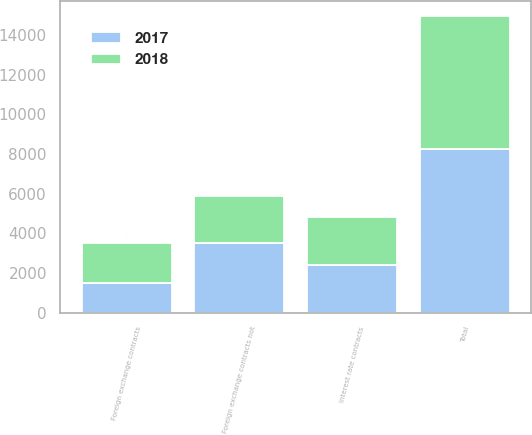Convert chart. <chart><loc_0><loc_0><loc_500><loc_500><stacked_bar_chart><ecel><fcel>Foreign exchange contracts<fcel>Foreign exchange contracts not<fcel>Interest rate contracts<fcel>Total<nl><fcel>2017<fcel>1510<fcel>3517<fcel>2400<fcel>8231<nl><fcel>2018<fcel>1990<fcel>2349<fcel>2400<fcel>6739<nl></chart> 